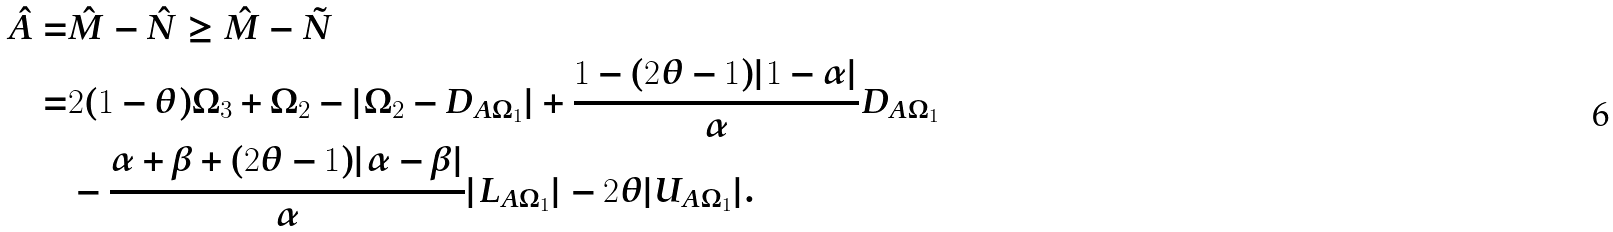Convert formula to latex. <formula><loc_0><loc_0><loc_500><loc_500>\hat { A } = & \hat { M } - \hat { N } \geq \hat { M } - \tilde { N } \\ = & 2 ( 1 - \theta ) \Omega _ { 3 } + \Omega _ { 2 } - | \Omega _ { 2 } - D _ { A \Omega _ { 1 } } | + \frac { 1 - ( 2 \theta - 1 ) | 1 - \alpha | } { \alpha } D _ { A \Omega _ { 1 } } \\ & - \frac { \alpha + \beta + ( 2 \theta - 1 ) | \alpha - \beta | } { \alpha } | L _ { A \Omega _ { 1 } } | - 2 \theta | U _ { A \Omega _ { 1 } } | .</formula> 